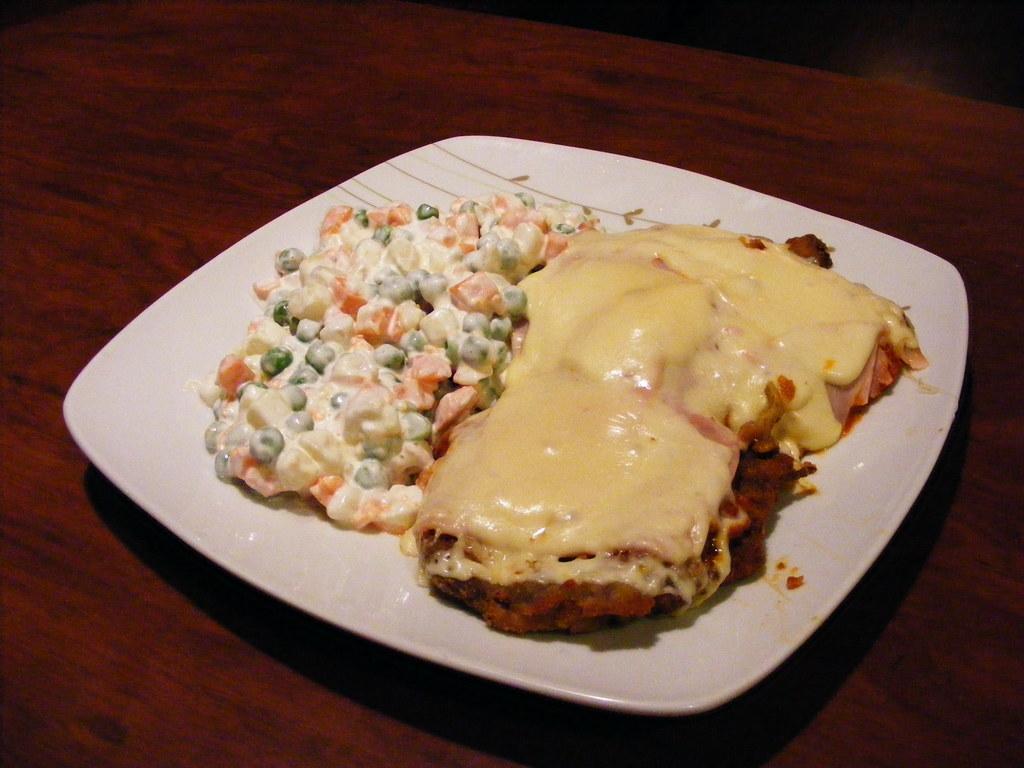Describe this image in one or two sentences. In this image we can see a plate containing food placed on the table. 